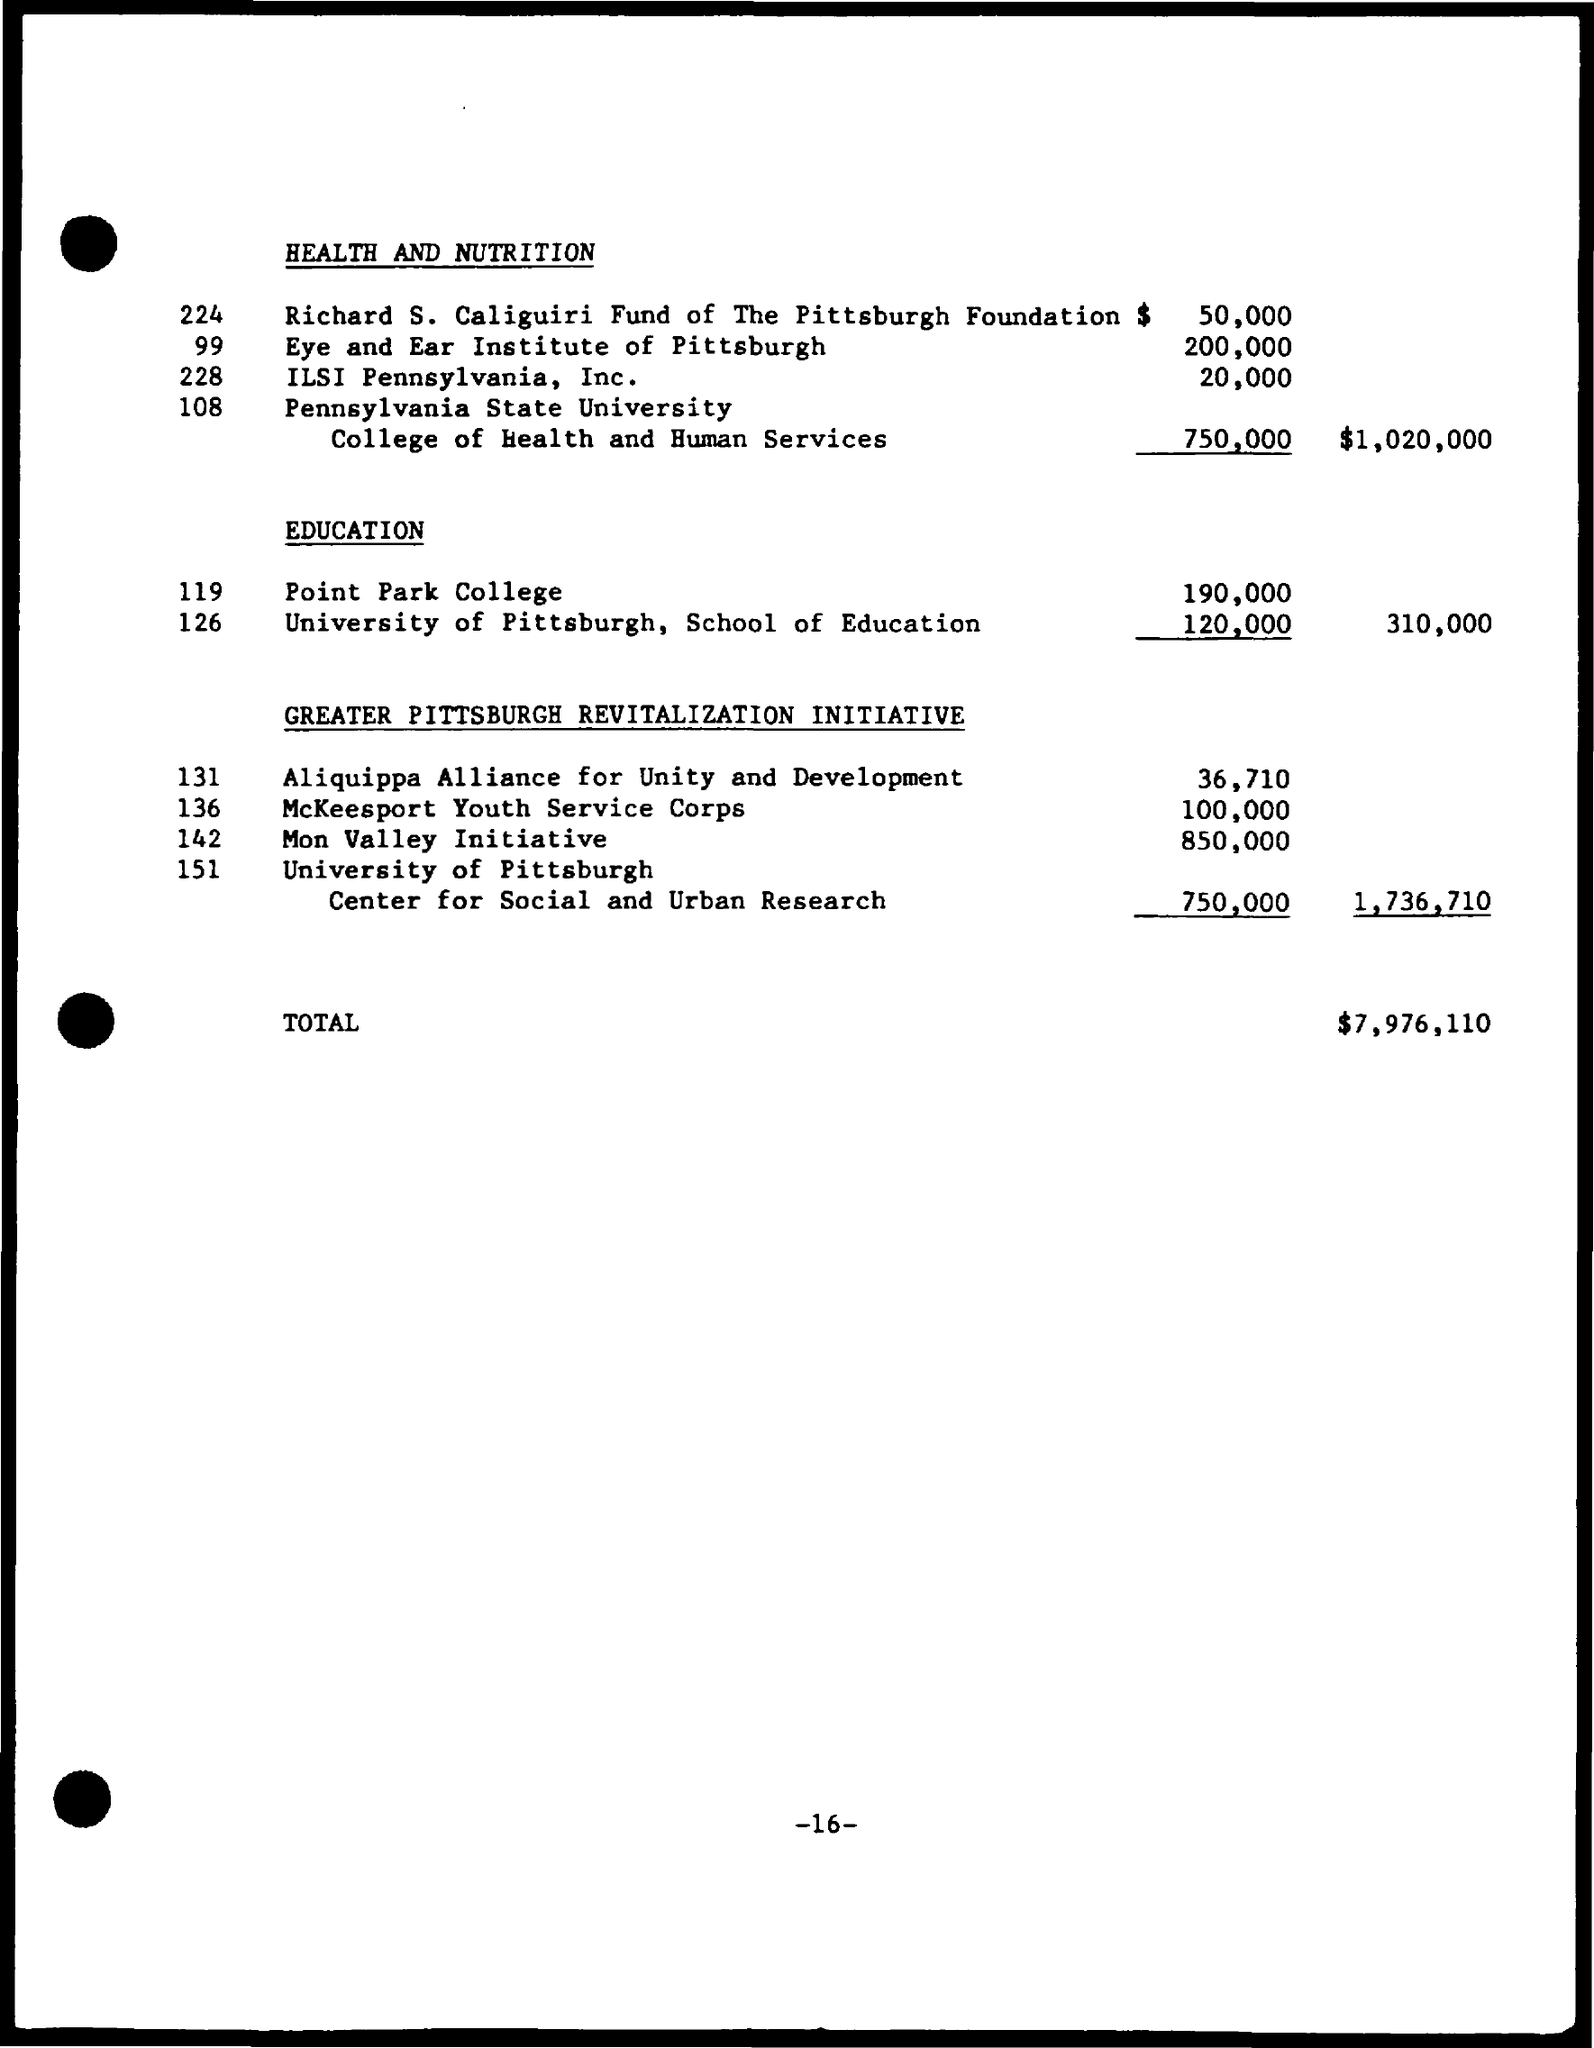What is the second title in the document?
Offer a very short reply. Education. What is the total currency?
Your answer should be very brief. $7,976,110. What is the first title in the document?
Provide a short and direct response. HEALTH AND NUTRITION. 